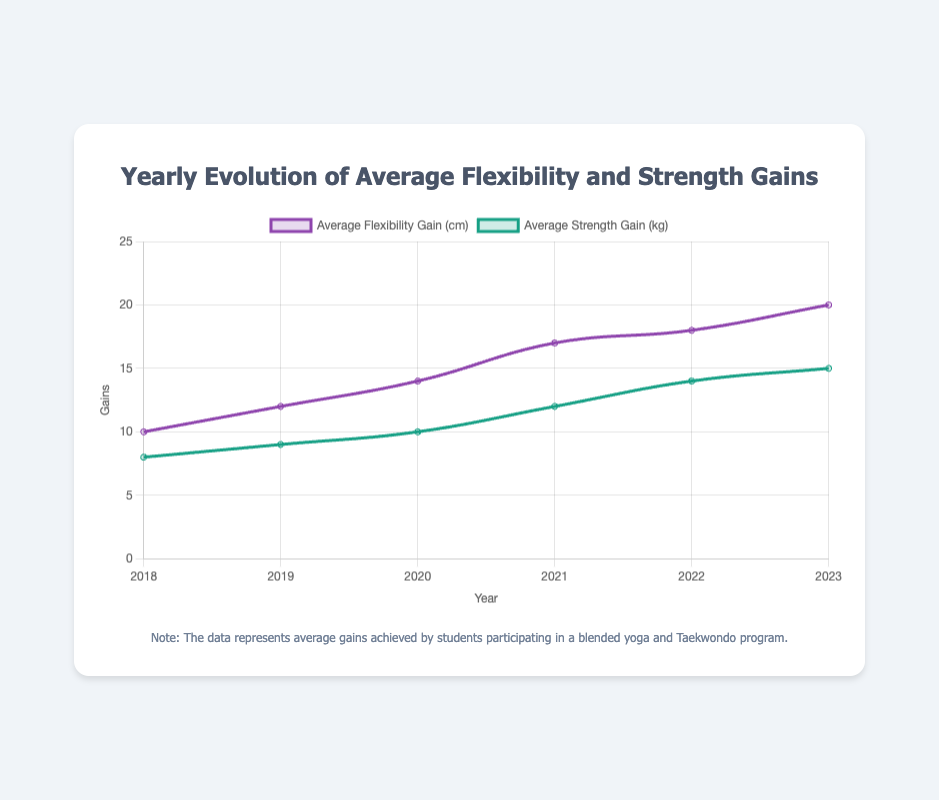What was the average flexibility gain in 2020? Look at the data points for "Average Flexibility Gain (cm)" in the year 2020, which is 14 cm.
Answer: 14 cm By how much did the average strength gain increase from 2018 to 2023? Find the difference between the average strength gain in 2023 (15 kg) and 2018 (8 kg). The increase is 15 - 8 = 7 kg.
Answer: 7 kg What is the total flexibility gain from 2018 to 2023? Sum the flexibility gains for all years from 2018 to 2023: 10 + 12 + 14 + 17 + 18 + 20. The total is 91 cm.
Answer: 91 cm Which year showed the largest increase in average flexibility gain from the previous year? Look at the differences between consecutive years: from 2018 to 2019 (2 cm), 2019 to 2020 (2 cm), 2020 to 2021 (3 cm), 2021 to 2022 (1 cm), 2022 to 2023 (2 cm). The largest increase is from 2020 to 2021 (3 cm).
Answer: 2021 In 2021, were the average flexibility gains greater than the strength gains? If so, by how much? In 2021, flexibility gain is 17 cm and strength gain is 12 kg. The difference is 17 - 12 = 5 (cm - kg). Flexibility gains were 5 units greater than strength gains.
Answer: 5 units What is the average yearly increase in flexibility gains from 2018 to 2023? Calculate the total flexibility gain (from 91 cm) and divide by the number of years (5). Average increase is 91/5 = 18.2 cm/year.
Answer: 18.2 cm/year Which dataset had a higher percentage increase from 2018 to 2023, flexibility or strength? Calculate percentage increase for flexibility: (20-10)/10 = 1 = 100%. For strength: (15-8)/8 = 0.875 = 87.5%. Flexibility had a higher percentage increase.
Answer: Flexibility By how much did the average strength gain change from 2020 to 2022? Subtract the average strength gain in 2020 (10 kg) from the gain in 2022 (14 kg), which is 14 - 10 = 4 kg.
Answer: 4 kg In which year did the average strength gain exceed 10 kg for the first time? Examine the strength gain data: 8, 9, 10, 12, 14, 15 kg. The first year it exceeds 10 kg is 2021.
Answer: 2021 How does the trend of flexibility gains compare visually to the trend of strength gains over the years? Observing both lines: flexibility gains show a relatively steady increase from 2018 to 2023. Strength gains also increase but at a slightly slower rate. Flexibility gains line is steeper.
Answer: Steeper for flexibility 